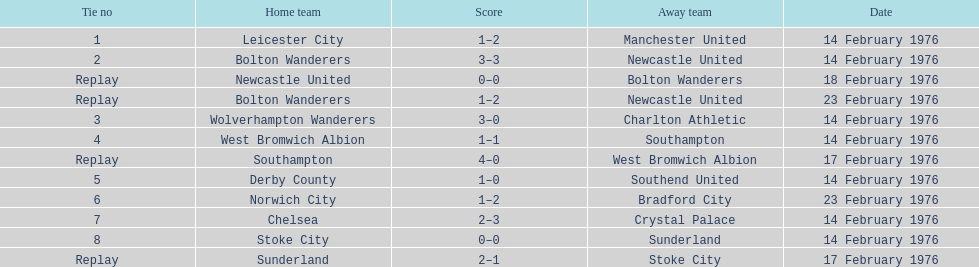Who obtained a better result, manchester united or wolverhampton wanderers? Wolverhampton Wanderers. 